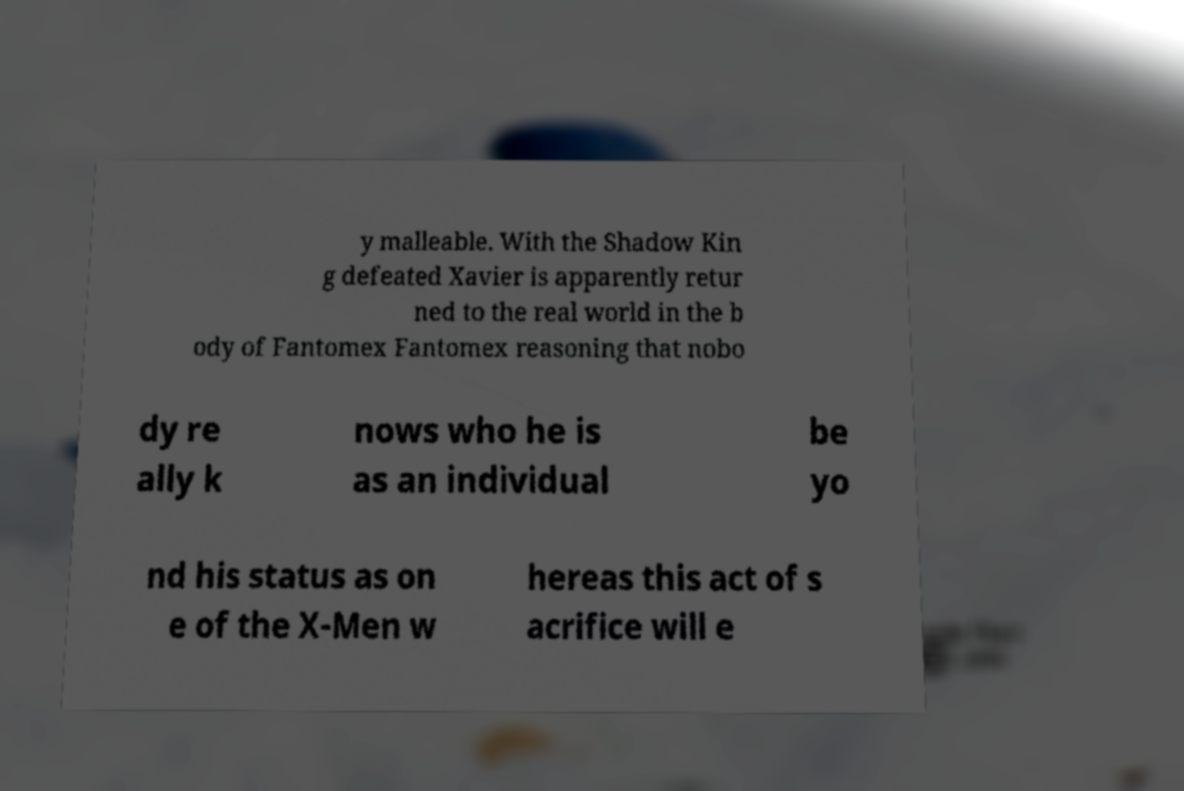I need the written content from this picture converted into text. Can you do that? y malleable. With the Shadow Kin g defeated Xavier is apparently retur ned to the real world in the b ody of Fantomex Fantomex reasoning that nobo dy re ally k nows who he is as an individual be yo nd his status as on e of the X-Men w hereas this act of s acrifice will e 